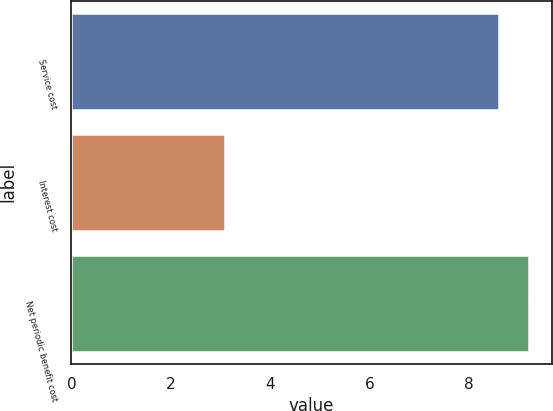<chart> <loc_0><loc_0><loc_500><loc_500><bar_chart><fcel>Service cost<fcel>Interest cost<fcel>Net periodic benefit cost<nl><fcel>8.6<fcel>3.1<fcel>9.21<nl></chart> 